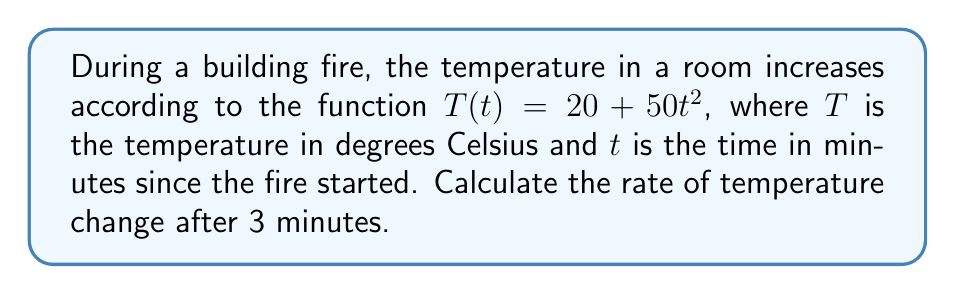Give your solution to this math problem. To find the rate of temperature change, we need to calculate the derivative of the temperature function $T(t)$ with respect to time $t$, and then evaluate it at $t = 3$ minutes.

Step 1: Find the derivative of $T(t)$
$$\frac{d}{dt}T(t) = \frac{d}{dt}(20 + 50t^2)$$
$$\frac{d}{dt}T(t) = 0 + 50 \cdot 2t$$
$$\frac{d}{dt}T(t) = 100t$$

Step 2: Evaluate the derivative at $t = 3$ minutes
$$\left.\frac{d}{dt}T(t)\right|_{t=3} = 100 \cdot 3 = 300$$

Therefore, the rate of temperature change after 3 minutes is 300 degrees Celsius per minute.
Answer: $300^\circ C/min$ 